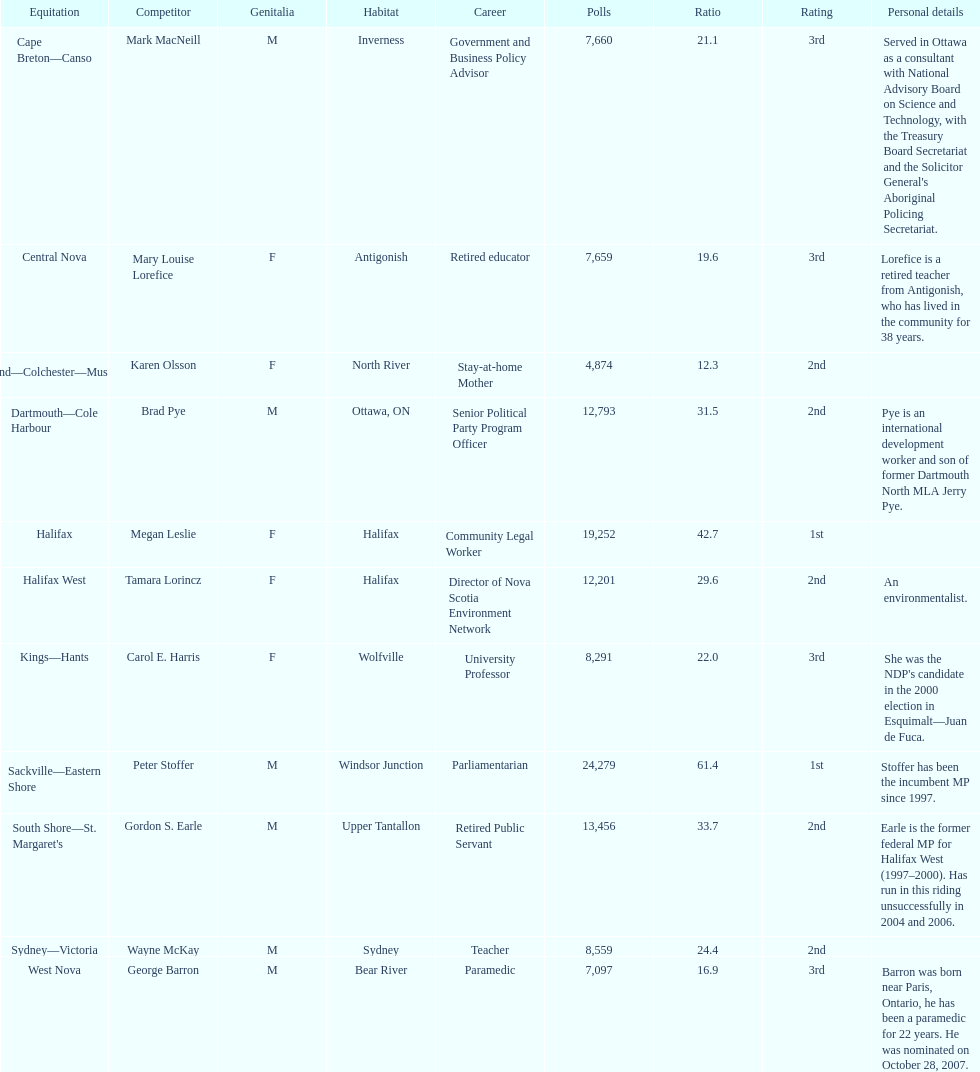Who received the least amount of votes? Karen Olsson. 